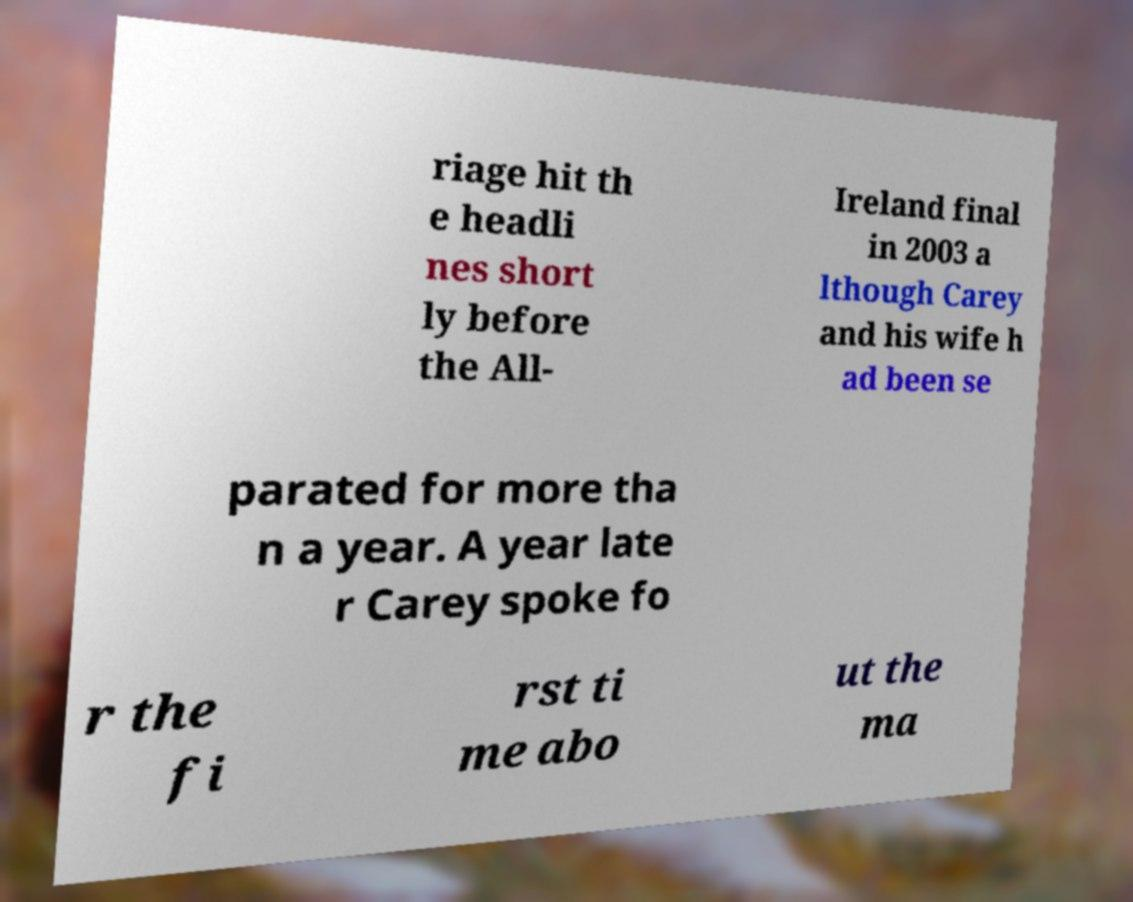What messages or text are displayed in this image? I need them in a readable, typed format. riage hit th e headli nes short ly before the All- Ireland final in 2003 a lthough Carey and his wife h ad been se parated for more tha n a year. A year late r Carey spoke fo r the fi rst ti me abo ut the ma 